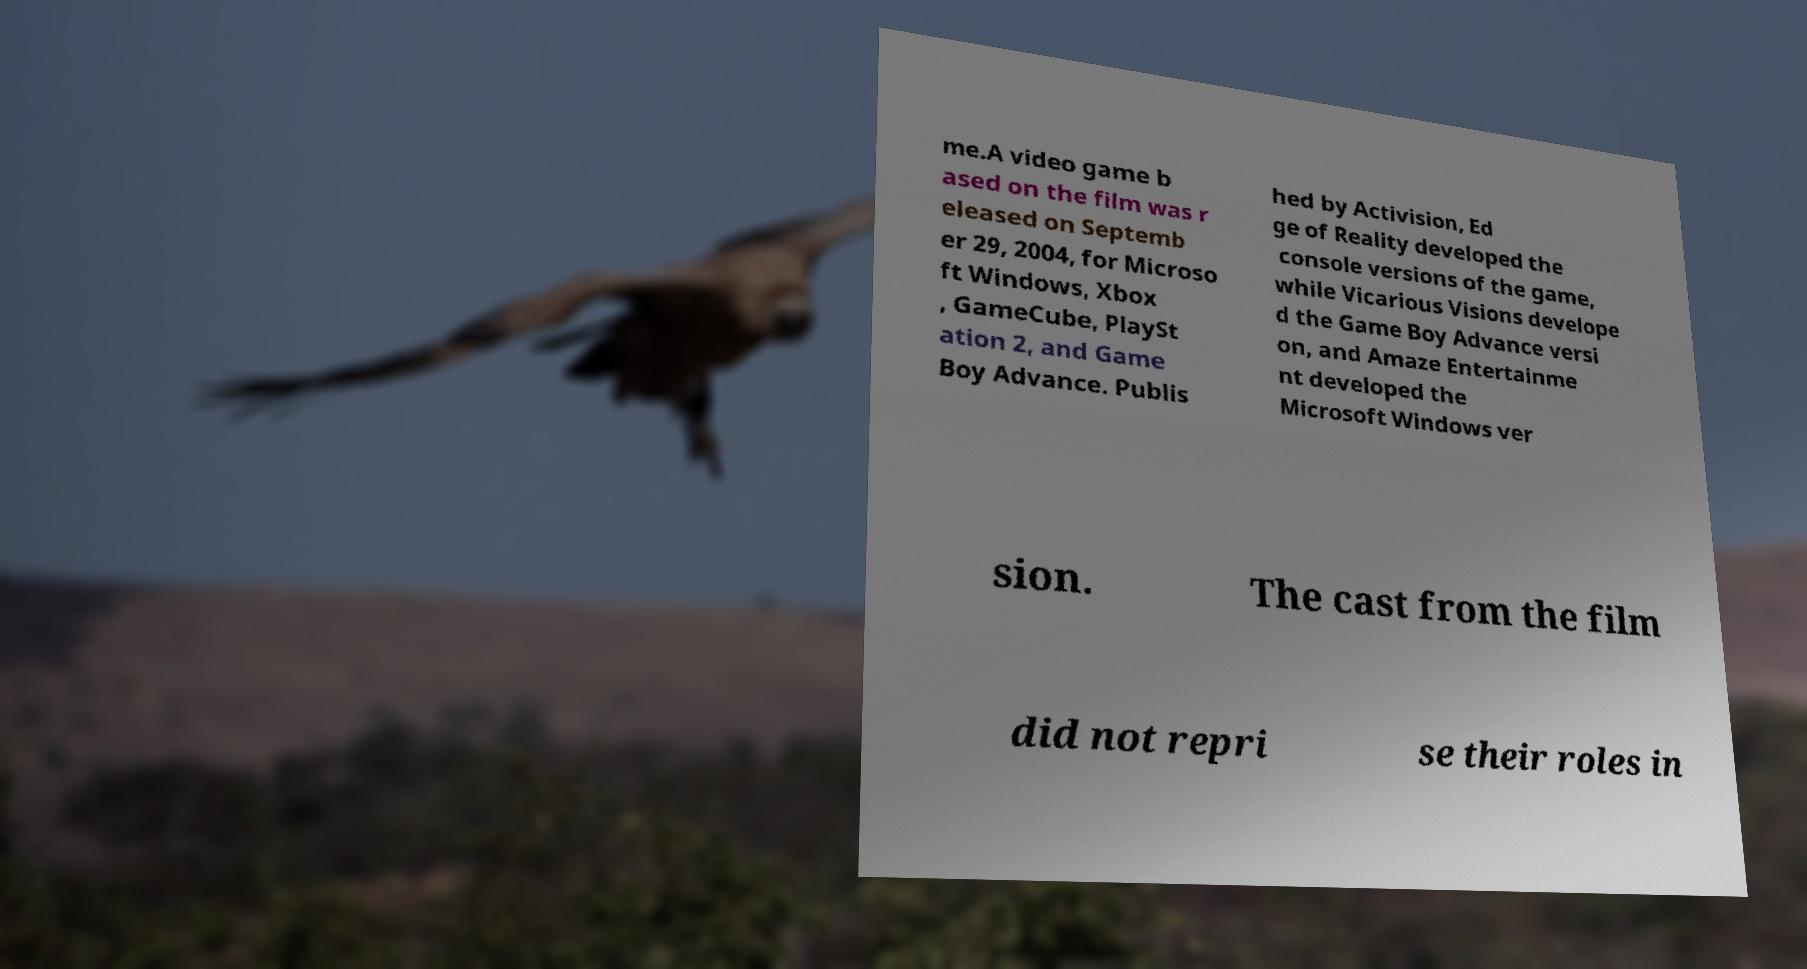Can you accurately transcribe the text from the provided image for me? me.A video game b ased on the film was r eleased on Septemb er 29, 2004, for Microso ft Windows, Xbox , GameCube, PlaySt ation 2, and Game Boy Advance. Publis hed by Activision, Ed ge of Reality developed the console versions of the game, while Vicarious Visions develope d the Game Boy Advance versi on, and Amaze Entertainme nt developed the Microsoft Windows ver sion. The cast from the film did not repri se their roles in 